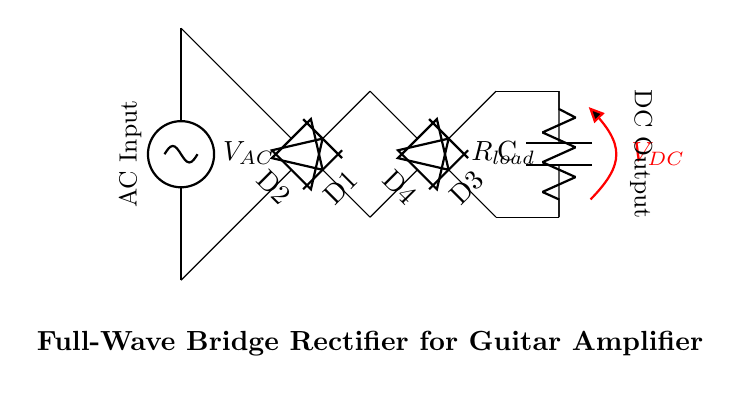What type of rectifier is shown in this circuit? The circuit diagram clearly illustrates a full-wave bridge rectifier configuration, which is characterized by four diodes arranged in a bridge topology.
Answer: full-wave bridge rectifier How many diodes are used in this circuit? The diagram displays four diodes (D1, D2, D3, D4), which are required for the full-wave bridge rectification process.
Answer: four What is the purpose of the capacitor in the circuit? The capacitor (C) is used to smooth out the pulsating DC output voltage by charging during peak voltage and discharging when the voltage drops, leading to a more constant DC output.
Answer: smoothing What is the output voltage labeled in the diagram? The output voltage from the bridge rectifier, after smoothing by the capacitor, is labeled as V DC, indicating the direct current voltage provided to the load.
Answer: V DC What type of load is represented in this circuit? The load resistor (R load) is a passive component that represents the impedance presented to the rectified output and can simulate a real-world load in applications like guitar amplifiers.
Answer: resistor How does this circuit convert AC to DC? The full-wave bridge rectifier utilizes both halves of the AC waveform. The diodes conduct based on the polarity of the AC voltage, allowing current to flow in the same direction through the load during both half-cycles, effectively converting AC into a unidirectional DC output.
Answer: by utilizing both halves of AC 